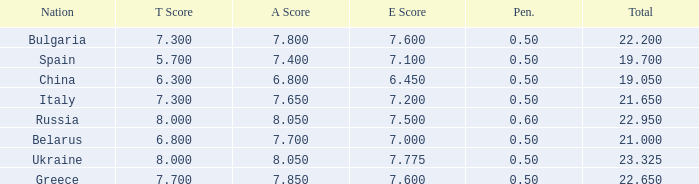What's the sum of A Score that also has a score lower than 7.3 and an E Score larger than 7.1? None. 